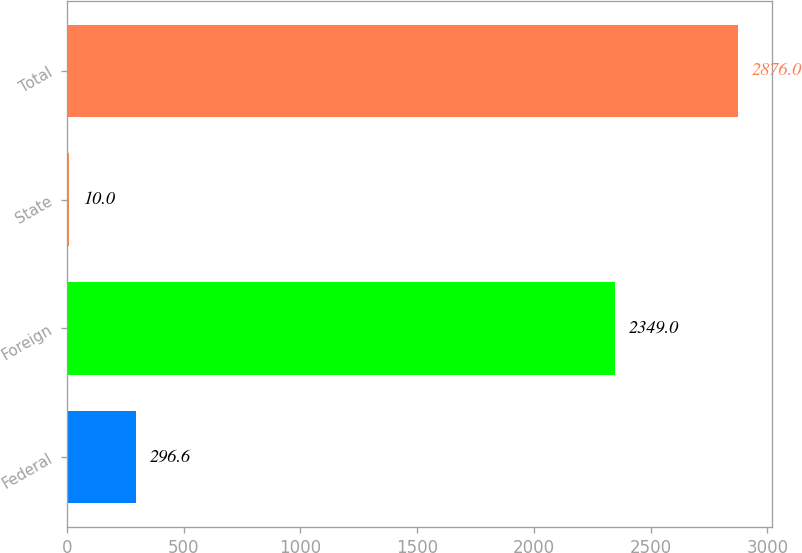Convert chart. <chart><loc_0><loc_0><loc_500><loc_500><bar_chart><fcel>Federal<fcel>Foreign<fcel>State<fcel>Total<nl><fcel>296.6<fcel>2349<fcel>10<fcel>2876<nl></chart> 